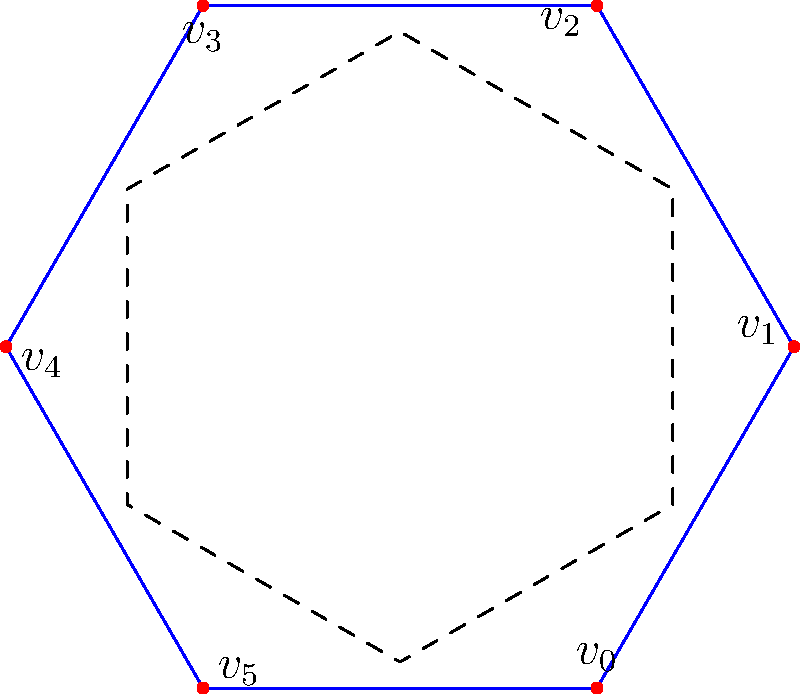A proposed eco-friendly community center in Arun District has a hexagonal floor plan. The dihedral group $D_6$ describes the symmetries of this floor plan. If a rotation of 30° clockwise is applied to the floor plan, followed by a reflection across the line connecting $v_0$ and $v_3$, what is the resulting transformation in terms of the generators of $D_6$? Let's approach this step-by-step:

1) In $D_6$, we have two generators:
   - $r$: rotation by 60° clockwise
   - $s$: reflection across the line connecting $v_0$ and $v_3$

2) The first transformation is a rotation of 30° clockwise. This is equivalent to $r^{1/2}$ (half of a basic rotation).

3) The second transformation is a reflection across the line connecting $v_0$ and $v_3$. This is exactly $s$.

4) To find the resulting transformation, we compose these operations: $s \circ r^{1/2}$

5) In group theory, we typically write compositions from right to left. So this becomes $sr^{1/2}$

6) However, $r^{1/2}$ is not an element of $D_6$. We need to express this in terms of the generators.

7) A 30° rotation followed by a reflection is equivalent to a reflection across a different axis, specifically the line that bisects the angle between $v_0$ and $v_5$.

8) This new reflection can be achieved by first rotating 30° counterclockwise (which is $r^5$ in $D_6$), then applying $s$, and then rotating 30° clockwise (which is $r$).

9) Therefore, the resulting transformation can be expressed as $rsr^5$.
Answer: $rsr^5$ 